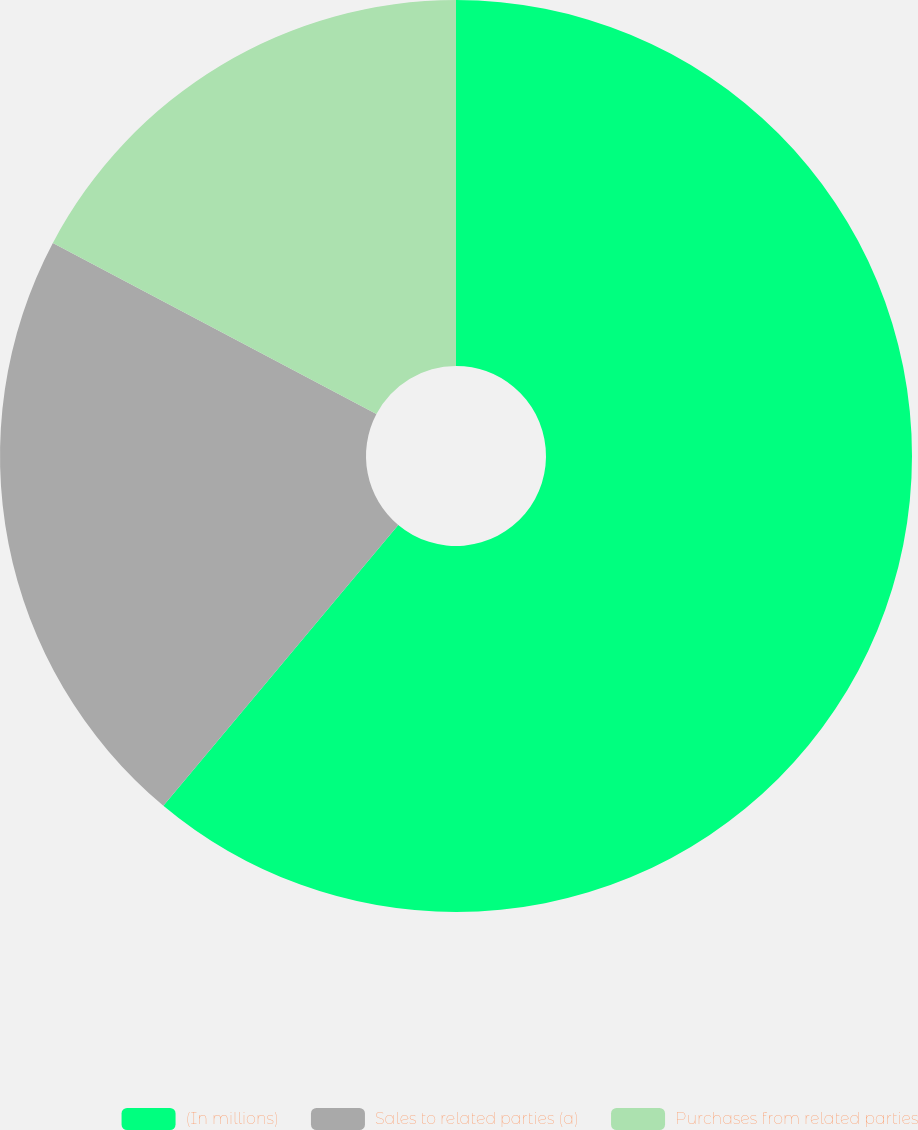<chart> <loc_0><loc_0><loc_500><loc_500><pie_chart><fcel>(In millions)<fcel>Sales to related parties (a)<fcel>Purchases from related parties<nl><fcel>61.09%<fcel>21.65%<fcel>17.26%<nl></chart> 